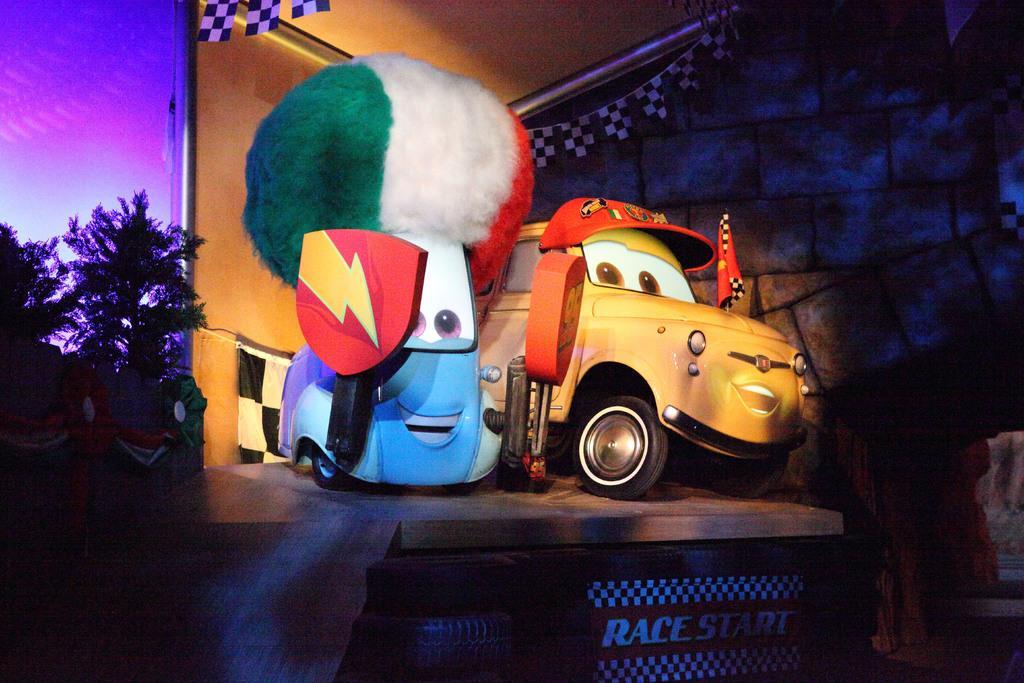Could you give a brief overview of what you see in this image? In the middle of the picture I can see toy cars on the wooden floor and there are trees on the left. And there is a wall in the background. 